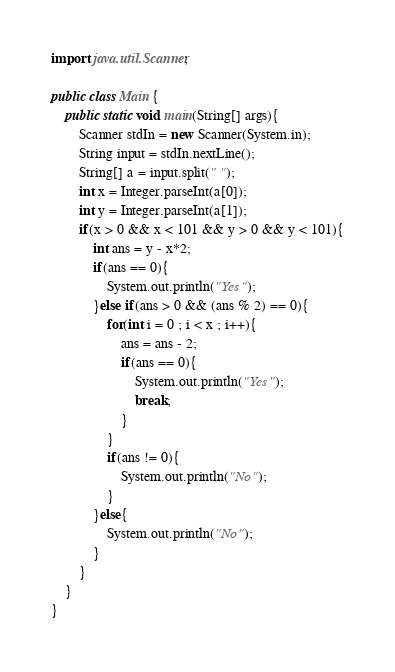<code> <loc_0><loc_0><loc_500><loc_500><_Java_>import java.util.Scanner;

public class Main {
    public static void main(String[] args){
        Scanner stdIn = new Scanner(System.in);
        String input = stdIn.nextLine();
        String[] a = input.split(" ");
        int x = Integer.parseInt(a[0]);
        int y = Integer.parseInt(a[1]);
        if(x > 0 && x < 101 && y > 0 && y < 101){
            int ans = y - x*2;
            if(ans == 0){
                System.out.println("Yes");
            }else if(ans > 0 && (ans % 2) == 0){
                for(int i = 0 ; i < x ; i++){
                    ans = ans - 2;
                    if(ans == 0){
                        System.out.println("Yes");
                        break;
                    }
                }
                if(ans != 0){
                    System.out.println("No");
                }
            }else{
                System.out.println("No");
            }
        }
    }
}
</code> 